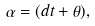<formula> <loc_0><loc_0><loc_500><loc_500>\alpha = ( d t + \theta ) ,</formula> 